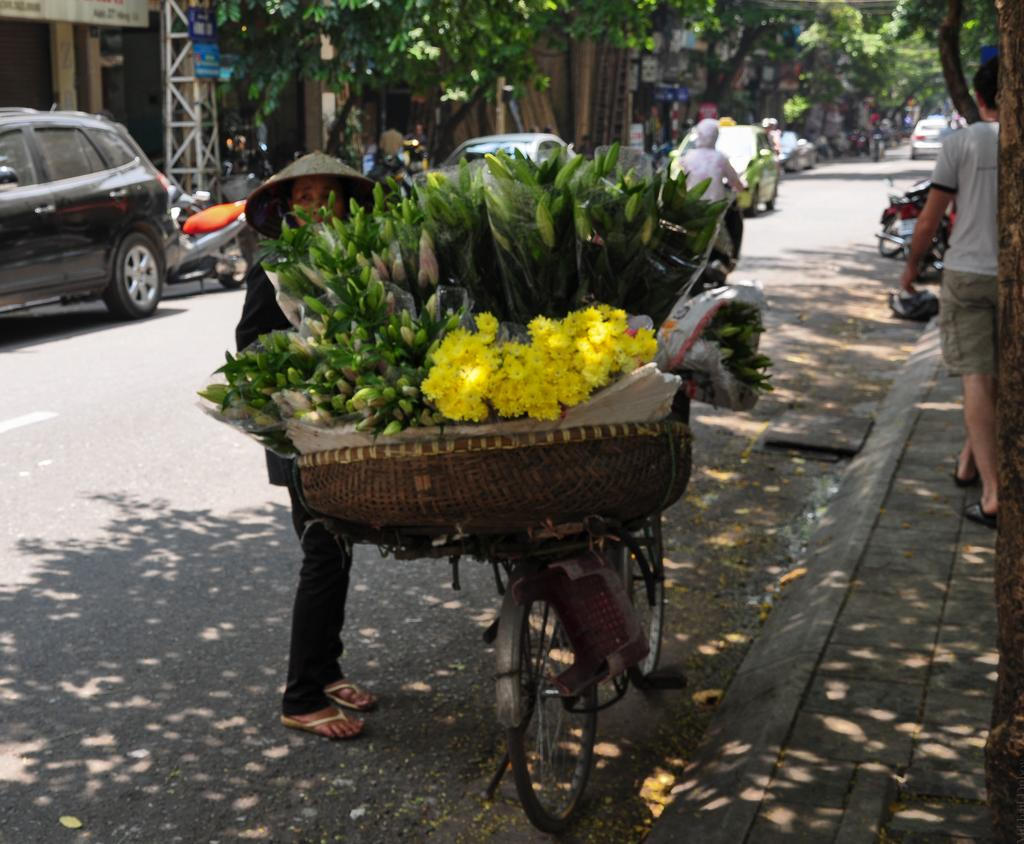What is the main object in the image? There is a bicycle in the image. What is in the basket attached to the bicycle? The bicycle has a basket with flowers. Who is near the bicycle? There is a person beside the bicycle. What can be seen on the road in the image? Vehicles are present on the road. What type of natural elements are visible in the image? Trees are visible in the image. Are there any other people in the image besides the person near the bicycle? Yes, people are present in the image. Can you tell me how many women are getting a haircut in the image? There is no woman getting a haircut in the image; it features a bicycle with a basket of flowers, a person, vehicles, trees, and other people. 